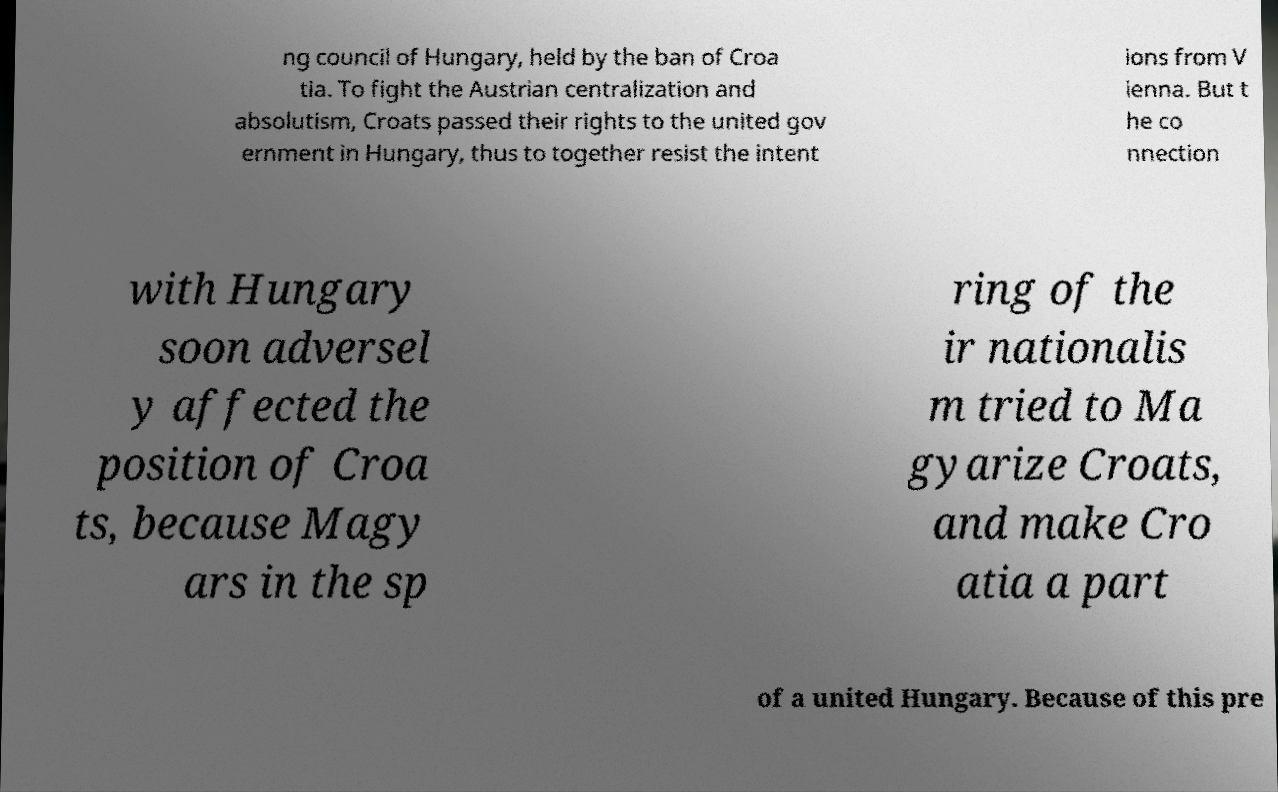Please read and relay the text visible in this image. What does it say? ng council of Hungary, held by the ban of Croa tia. To fight the Austrian centralization and absolutism, Croats passed their rights to the united gov ernment in Hungary, thus to together resist the intent ions from V ienna. But t he co nnection with Hungary soon adversel y affected the position of Croa ts, because Magy ars in the sp ring of the ir nationalis m tried to Ma gyarize Croats, and make Cro atia a part of a united Hungary. Because of this pre 